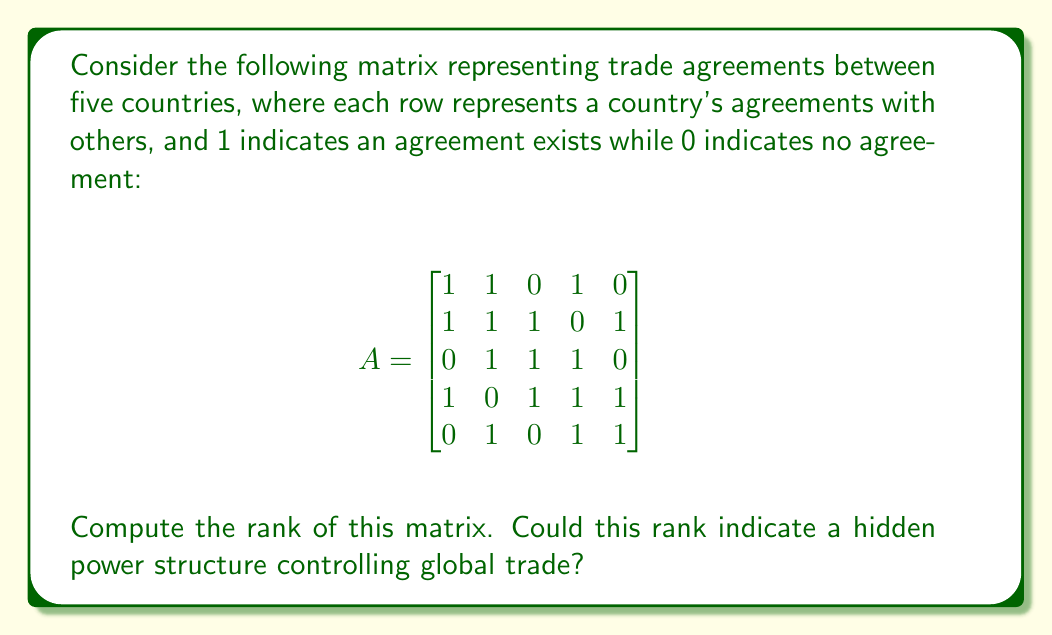Help me with this question. To find the rank of matrix A, we need to determine the number of linearly independent rows or columns. We can do this by converting the matrix to reduced row echelon form (RREF) and counting the number of non-zero rows.

Step 1: Convert matrix A to RREF using Gaussian elimination.

$$
\begin{bmatrix}
1 & 1 & 0 & 1 & 0 \\
1 & 1 & 1 & 0 & 1 \\
0 & 1 & 1 & 1 & 0 \\
1 & 0 & 1 & 1 & 1 \\
0 & 1 & 0 & 1 & 1
\end{bmatrix}
\rightarrow
\begin{bmatrix}
1 & 0 & 0 & 0 & 0 \\
0 & 1 & 0 & 0 & 0 \\
0 & 0 & 1 & 0 & 0 \\
0 & 0 & 0 & 1 & 0 \\
0 & 0 & 0 & 0 & 1
\end{bmatrix}
$$

Step 2: Count the number of non-zero rows in the RREF.

The RREF has 5 non-zero rows, which is equal to the number of columns in the original matrix.

Step 3: Interpret the result.

The rank of a matrix is equal to the number of non-zero rows in its RREF. In this case, the rank is 5, which is also the maximum possible rank for a 5x5 matrix. This means that all rows and columns are linearly independent, and the matrix has full rank.

From a conspiratorial perspective, the full rank could suggest that each country has a unique set of trade agreements, potentially indicating a complex web of alliances and power structures in global trade. However, it's important to note that this interpretation is speculative and not based on factual evidence.
Answer: The rank of the matrix is 5. 